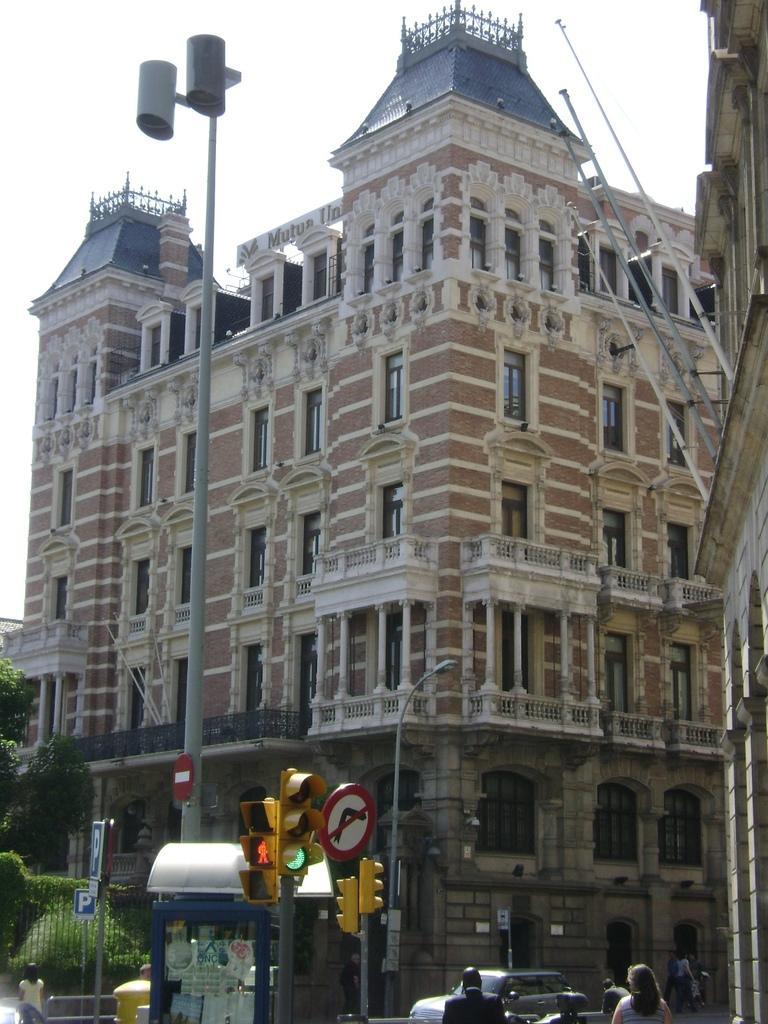Describe this image in one or two sentences. In this picture we can see a building here, at the bottom there are some people standing, we can see traffic lights and a pole here, on the left side there is a tree, we can see the sky at the top of the picture. 